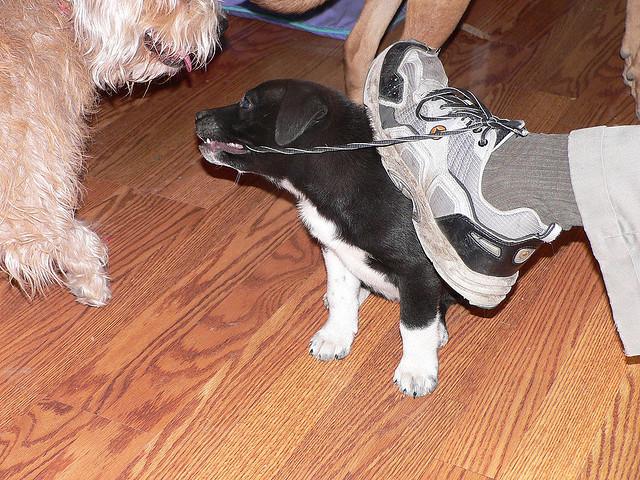How many dogs are there?
Keep it brief. 2. Is the dog behaving well?
Answer briefly. No. What is in the dogs mouth?
Short answer required. Shoelace. 